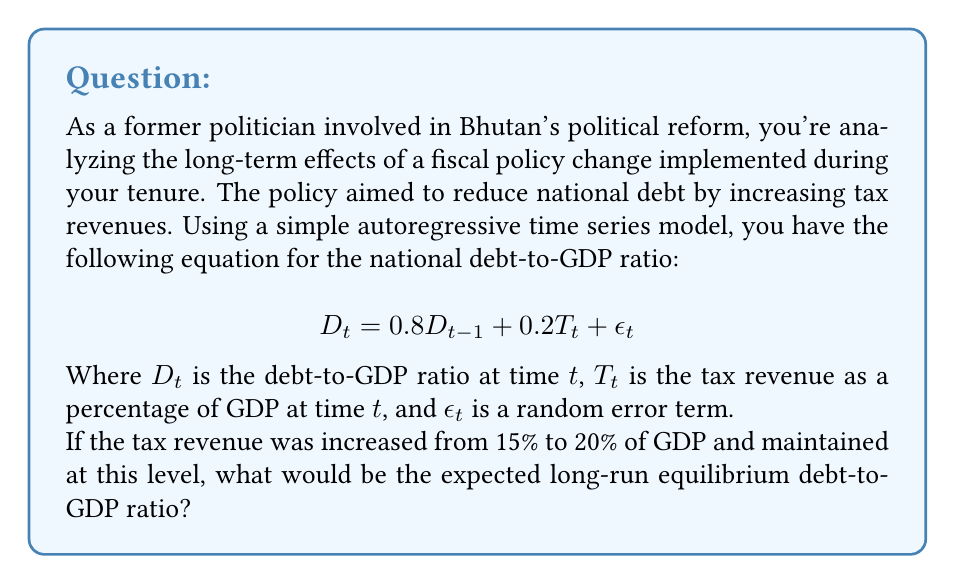Help me with this question. To solve this problem, we need to follow these steps:

1) In the long-run equilibrium, we expect $D_t = D_{t-1} = D^*$ (where $D^*$ is the equilibrium debt-to-GDP ratio) and we can ignore the error term $\epsilon_t$ as its expected value is zero.

2) We can rewrite the equation as:

   $$D^* = 0.8D^* + 0.2T^*$$

   Where $T^*$ is the new constant tax revenue (20% of GDP).

3) Simplify the equation:

   $$D^* - 0.8D^* = 0.2T^*$$
   $$0.2D^* = 0.2T^*$$

4) Solve for $D^*$:

   $$D^* = T^*$$

5) Substitute the value of $T^*$:

   $$D^* = 20\%$$

Therefore, the expected long-run equilibrium debt-to-GDP ratio is equal to the tax revenue as a percentage of GDP, which is 20%.
Answer: 20% 